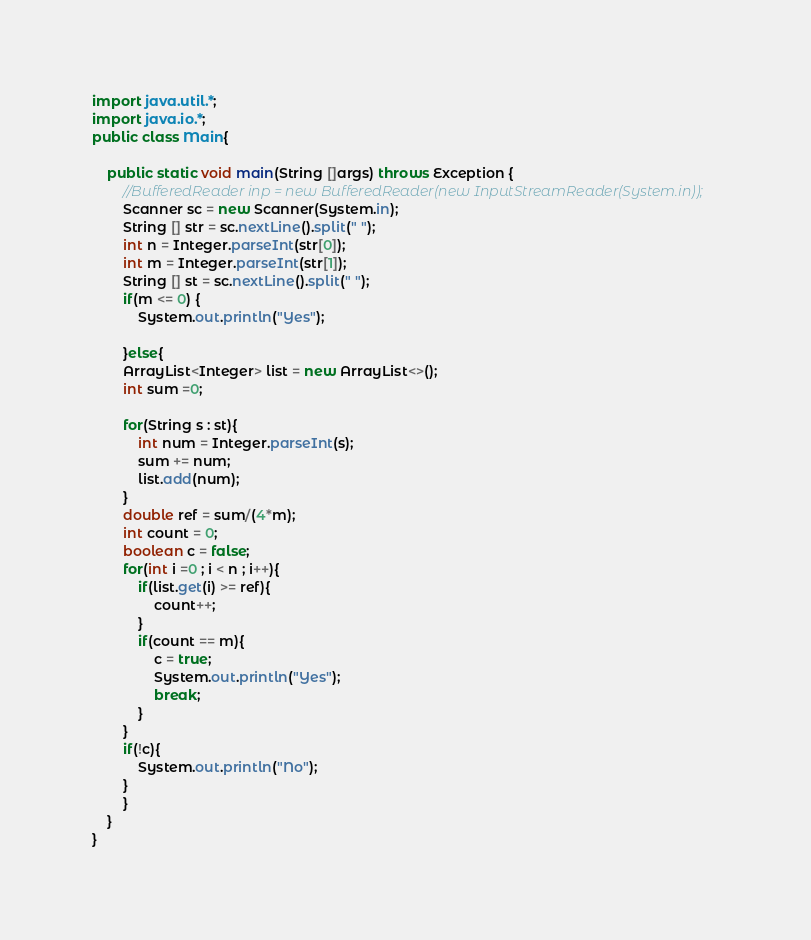<code> <loc_0><loc_0><loc_500><loc_500><_Java_>import java.util.*;
import java.io.*;
public class Main{

    public static void main(String []args) throws Exception {
        //BufferedReader inp = new BufferedReader(new InputStreamReader(System.in));
        Scanner sc = new Scanner(System.in);
        String [] str = sc.nextLine().split(" ");
        int n = Integer.parseInt(str[0]);
        int m = Integer.parseInt(str[1]);
        String [] st = sc.nextLine().split(" ");
        if(m <= 0) {
            System.out.println("Yes");
            
        }else{
        ArrayList<Integer> list = new ArrayList<>();
        int sum =0;
        
        for(String s : st){
            int num = Integer.parseInt(s);
            sum += num;
            list.add(num);
        }
        double ref = sum/(4*m);
        int count = 0;
        boolean c = false;
        for(int i =0 ; i < n ; i++){
            if(list.get(i) >= ref){
                count++;
            }
            if(count == m){
                c = true;
                System.out.println("Yes");
                break;
            }
        }
        if(!c){
            System.out.println("No");
        }
        }
    }
}</code> 